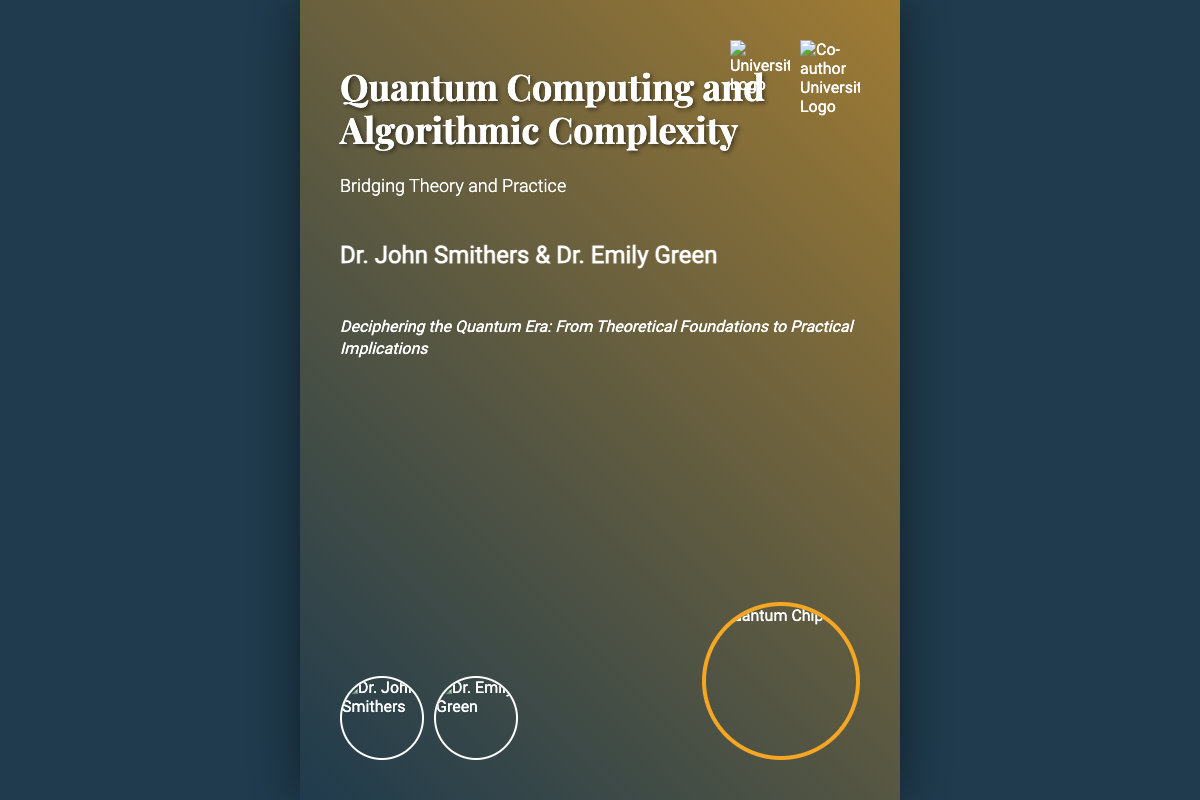What is the title of the book? The title of the book is indicated prominently at the top of the cover.
Answer: Quantum Computing and Algorithmic Complexity Who are the authors? The authors' names are listed under the title on the cover.
Answer: Dr. John Smithers & Dr. Emily Green What is the subtitle of the book? The subtitle appears just below the title and highlights the theme of the book.
Answer: Bridging Theory and Practice What is the tagline of the book? The tagline gives insight into the book's focus and aim, located below the authors' names.
Answer: Deciphering the Quantum Era: From Theoretical Foundations to Practical Implications What type of image is featured on the book cover? The cover features a background image representing a concept in quantum computing.
Answer: Quantum circuit What color is the background overlay? The overlay features a gradient of colors that enhances the visual aesthetics of the cover.
Answer: Blue and orange How many author photos are displayed on the cover? The cover displays individual photos of both authors.
Answer: Two Which university logo appears on the cover? The cover includes logos representing each author's affiliated institution.
Answer: University Logo What style of font is used for the book title? The title is emphasized using a specific font style to convey significance.
Answer: Playfair Display 